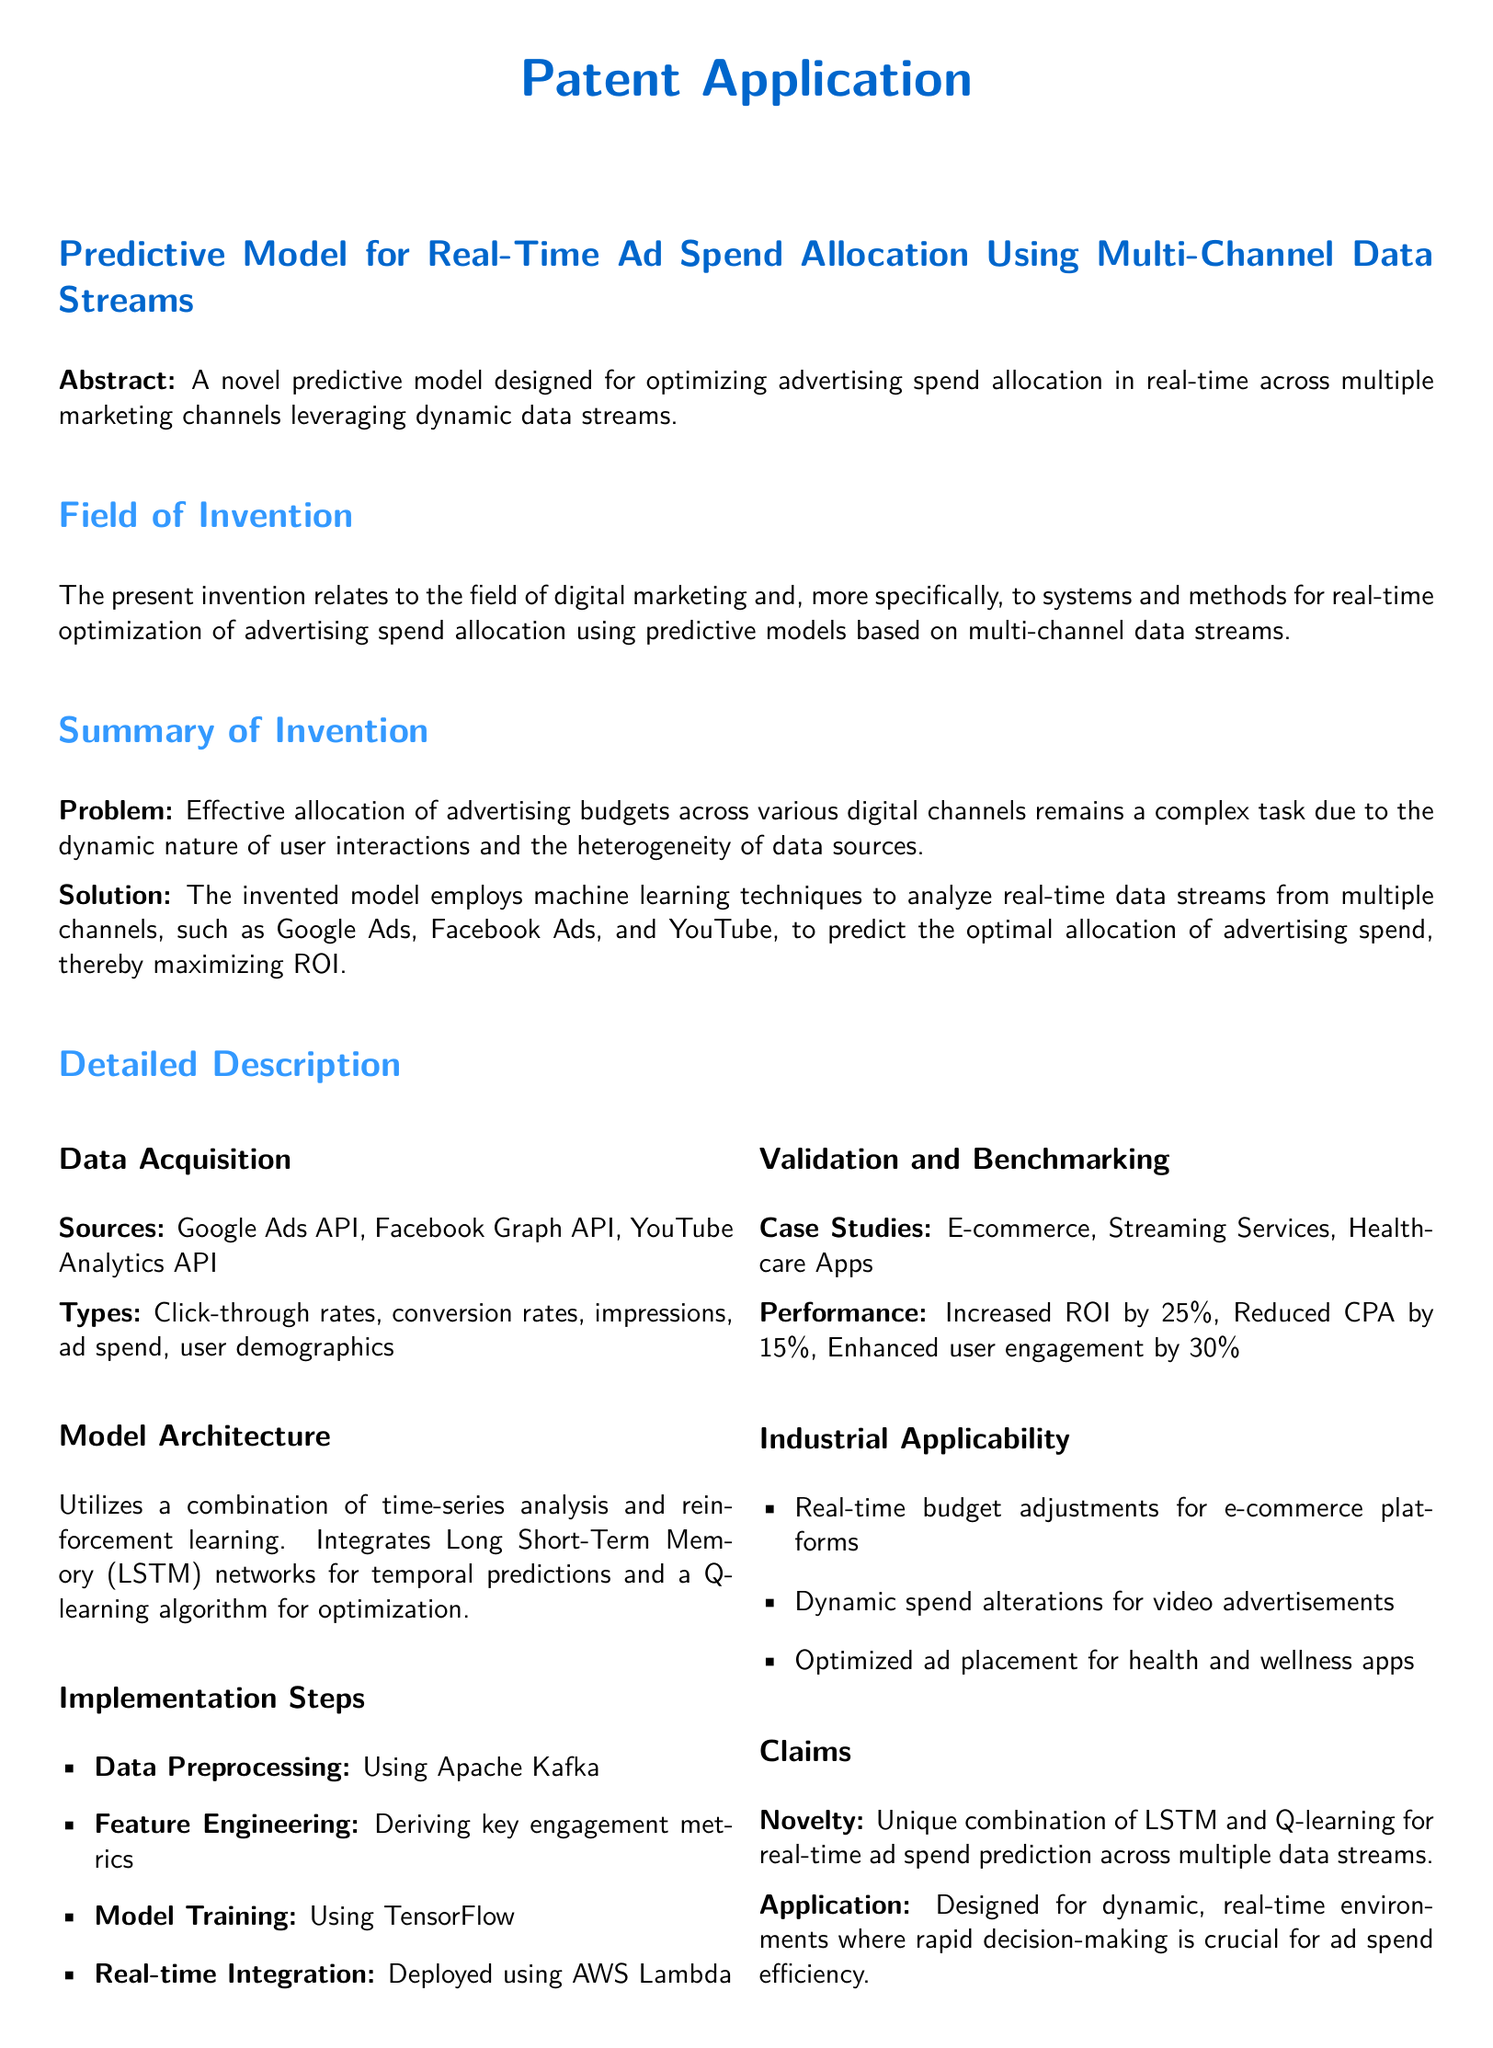What is the title of the patent? The title of the patent is stated in the document under the Predictive Model section.
Answer: Predictive Model for Real-Time Ad Spend Allocation Using Multi-Channel Data Streams What type of techniques does the model employ? The model utilizes specific methodologies described in the Summary of Invention section.
Answer: Machine learning techniques What was the increase in ROI reported? The performance metrics for the case studies mention specific percentages of improvement.
Answer: 25 percent Which API is not mentioned as a data source? The document lists specific APIs under the Data Acquisition section, indicating which are included and which are not.
Answer: None What is the unique combination used in the claimed novelty? The Claims section describes the unique methods employed in the model.
Answer: LSTM and Q-learning In which environment is the model designed to operate? The Claims section implies the type of operational context for the application of the model.
Answer: Dynamic, real-time environments What tool was used for model training? The implementation steps detail the specific tool used for training purposes.
Answer: TensorFlow What is the reduction in CPA reported? The performance metrics state specific improvements regarding cost metrics.
Answer: 15 percent Which industries can apply this model? The Industrial Applicability section lists potential sectors for application.
Answer: E-commerce, Streaming Services, Healthcare Apps 